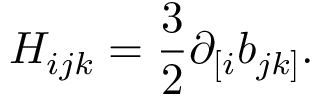<formula> <loc_0><loc_0><loc_500><loc_500>H _ { i j k } = \frac { 3 } { 2 } \partial _ { [ i } b _ { j k ] } .</formula> 